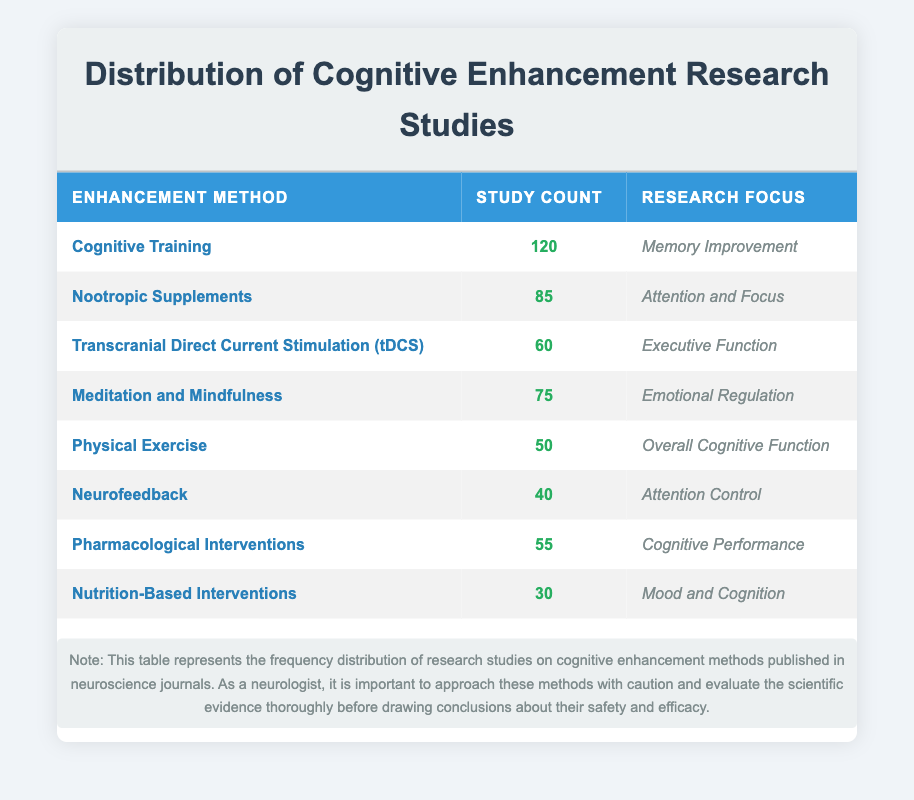What enhancement method has the highest number of studies? The method with the highest study count is Cognitive Training, which has 120 studies published. This can be readily identified by looking at the study counts in the table.
Answer: Cognitive Training What is the study count for Nutrition-Based Interventions? The study count for Nutrition-Based Interventions, as indicated in the table, is 30.
Answer: 30 Which two enhancement methods focus on Attention-related outcomes? The two methods focusing on Attention-related outcomes are Nootropic Supplements and Neurofeedback, with study counts of 85 and 40, respectively. This information is derived by looking for methods whose research focus mentions "Attention."
Answer: Nootropic Supplements and Neurofeedback What is the total number of studies for all methods combined? To find the total number of studies, we sum the study counts of all methods: (120 + 85 + 60 + 75 + 50 + 40 + 55 + 30) = 515. The summation of these values gives us the total count.
Answer: 515 Is there a cognitive enhancement method that has fewer than 50 studies published? Yes, there are two methods that have fewer than 50 studies published: Physical Exercise (50) and Nutrition-Based Interventions (30). Both values can be verified in the table; however, only Nutrition-Based Interventions is strictly fewer than 50.
Answer: Yes Which method has a greater focus, Memory Improvement or Emotional Regulation, in terms of study count? Memory Improvement is the focus for Cognitive Training, which has 120 studies, whereas Emotional Regulation is the focus for Meditation and Mindfulness, which has 75 studies. Since 120 is greater than 75, Memory Improvement has the greater focus based on the overall study count.
Answer: Memory Improvement What is the average number of studies published per enhancement method? There are 8 enhancement methods, with a total of 515 studies. To find the average, we divide the total number of studies by the number of methods: 515 / 8 = 64.375. This calculation shows how the total studies distribute across the methods.
Answer: 64.375 Are there any cognitive enhancement methods focusing on Overall Cognitive Function? Yes, the method focusing on Overall Cognitive Function is Physical Exercise, as indicated in the focus column of the table. This question can be answered by locating this specific focus in the table.
Answer: Yes Which enhancement method has the fewest studies published, and what is the study count? The enhancement method with the fewest studies published is Nutrition-Based Interventions, with a study count of 30. This can be identified by examining the study counts in ascending order.
Answer: Nutrition-Based Interventions, 30 